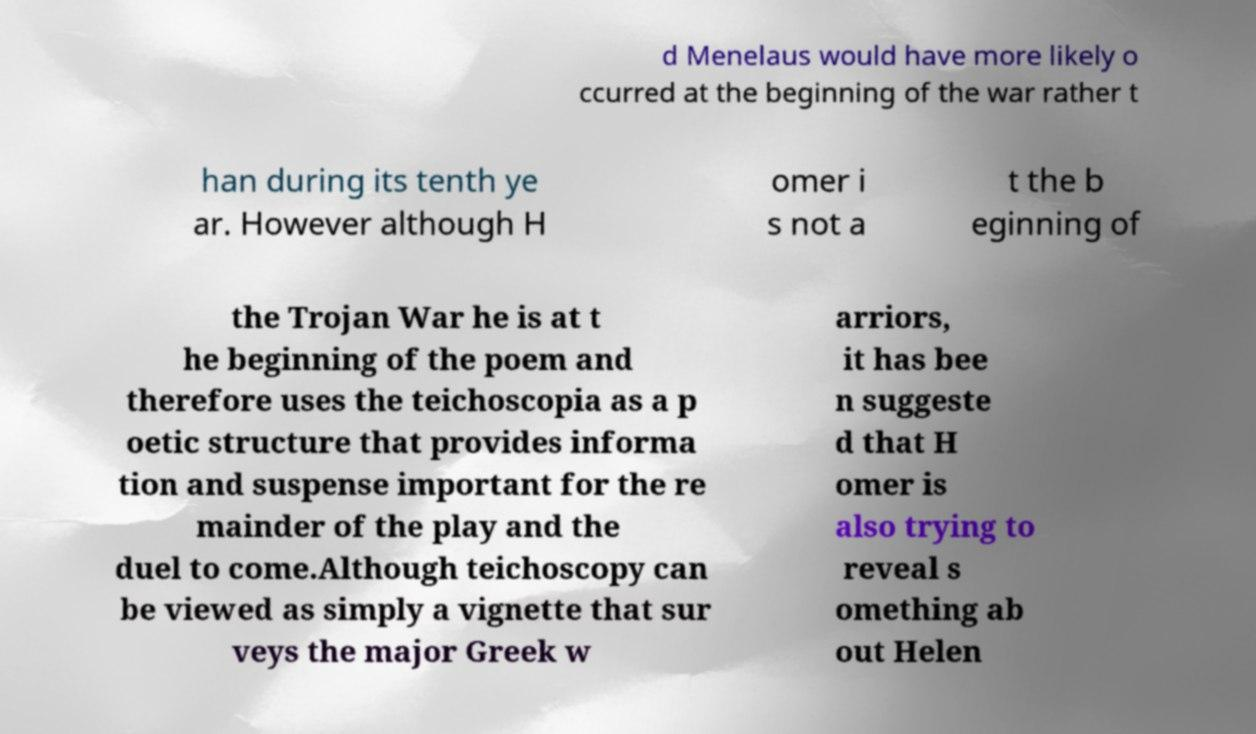Could you extract and type out the text from this image? d Menelaus would have more likely o ccurred at the beginning of the war rather t han during its tenth ye ar. However although H omer i s not a t the b eginning of the Trojan War he is at t he beginning of the poem and therefore uses the teichoscopia as a p oetic structure that provides informa tion and suspense important for the re mainder of the play and the duel to come.Although teichoscopy can be viewed as simply a vignette that sur veys the major Greek w arriors, it has bee n suggeste d that H omer is also trying to reveal s omething ab out Helen 